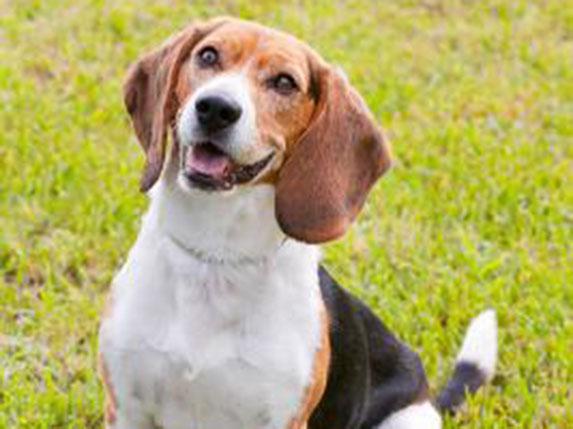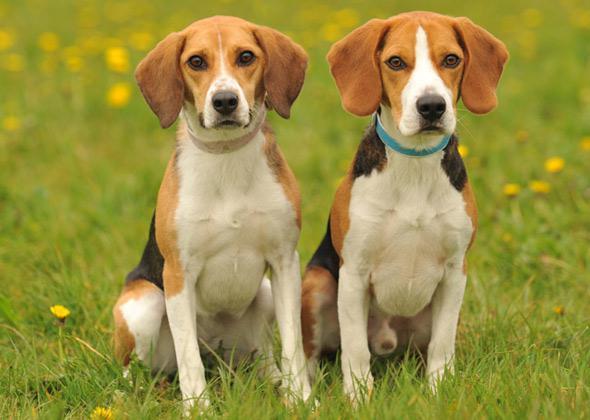The first image is the image on the left, the second image is the image on the right. Analyze the images presented: Is the assertion "There are exactly four dogs, and at least two of them seem to be puppies." valid? Answer yes or no. No. The first image is the image on the left, the second image is the image on the right. Examine the images to the left and right. Is the description "Two camera-facing beagles of similar size and coloring sit upright in the grass, and neither are young puppies." accurate? Answer yes or no. Yes. 